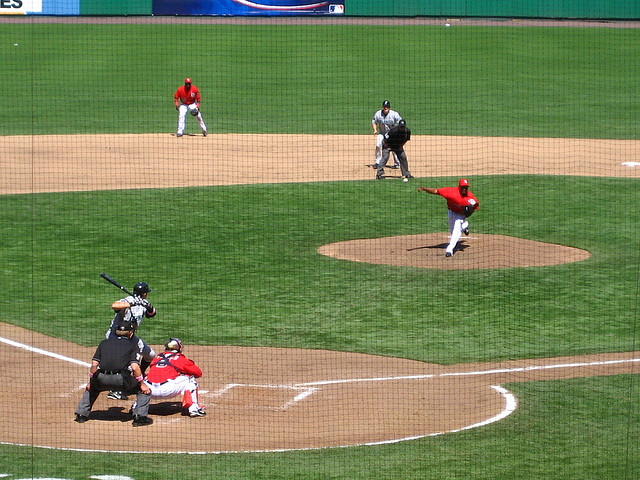What are some notable aspects of the pitcher's technique? The pitcher's form is a crucial aspect of his delivery. His leg is raised for balance and power, which will be transferred into the pitch. His arm is extended back and preparing to come over the top in a downward motion, which is characteristic of a fastball or slider. His eyes are fixed on the catcher's mitt to improve accuracy. Pitching is both an art and science, and his technique suggests he has trained extensively to refine his throwing motion. 